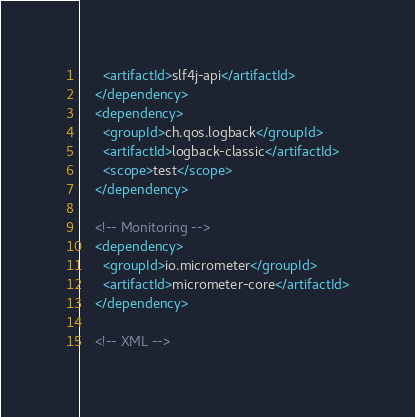Convert code to text. <code><loc_0><loc_0><loc_500><loc_500><_XML_>      <artifactId>slf4j-api</artifactId>
    </dependency>
    <dependency>
      <groupId>ch.qos.logback</groupId>
      <artifactId>logback-classic</artifactId>
      <scope>test</scope>
    </dependency>

    <!-- Monitoring -->
    <dependency>
      <groupId>io.micrometer</groupId>
      <artifactId>micrometer-core</artifactId>
    </dependency>

    <!-- XML --></code> 